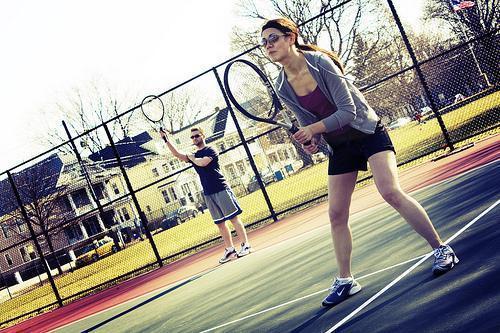How many tennis people are in the picture?
Give a very brief answer. 2. 